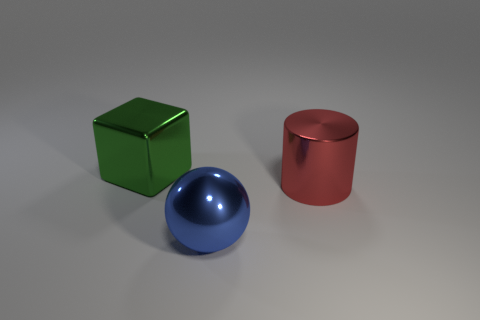What number of objects are objects in front of the large cube or metallic objects behind the large blue ball?
Provide a succinct answer. 3. Is the blue metal sphere the same size as the green object?
Make the answer very short. Yes. Is there any other thing that has the same size as the green block?
Your answer should be compact. Yes. Is the shape of the object that is in front of the large red object the same as the shiny object to the left of the metal ball?
Your answer should be compact. No. How big is the red metallic thing?
Offer a very short reply. Large. The large cylinder that is right of the large thing in front of the metal object to the right of the large blue metal object is made of what material?
Make the answer very short. Metal. What number of other objects are the same color as the cube?
Offer a very short reply. 0. What number of yellow objects are either shiny cylinders or large metal objects?
Make the answer very short. 0. What material is the object that is behind the big red shiny thing?
Keep it short and to the point. Metal. Is the material of the big ball that is in front of the big red metallic cylinder the same as the large green object?
Your response must be concise. Yes. 